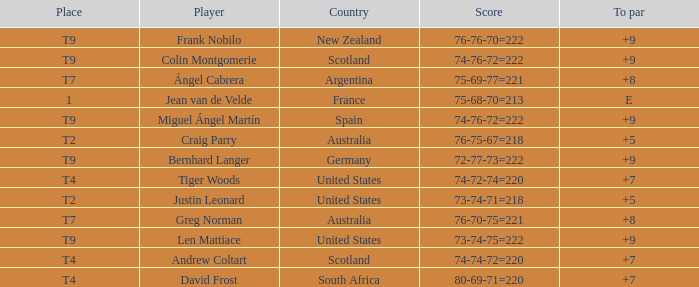What was the concluding score in the match where david frost had a to par of +7? 80-69-71=220. 